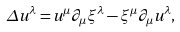Convert formula to latex. <formula><loc_0><loc_0><loc_500><loc_500>\Delta u ^ { \lambda } = u ^ { \mu } \partial _ { \mu } \xi ^ { \lambda } - \xi ^ { \mu } \partial _ { \mu } u ^ { \lambda } ,</formula> 